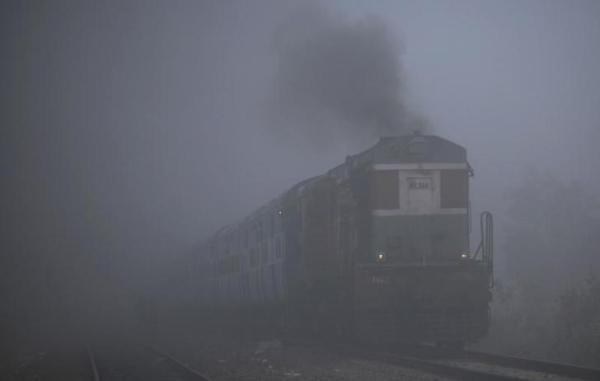How does the fog affect the visibility in this image? The dense fog significantly reduces visibility, blanketing the surroundings in a haze that obscures the train's details and the landscape beyond. Could you infer the time of day from the image? Inferring the exact time of day is challenging due to the fog, but it seems to be during daytime since there is enough light to illuminate the scene despite the fog's density. 